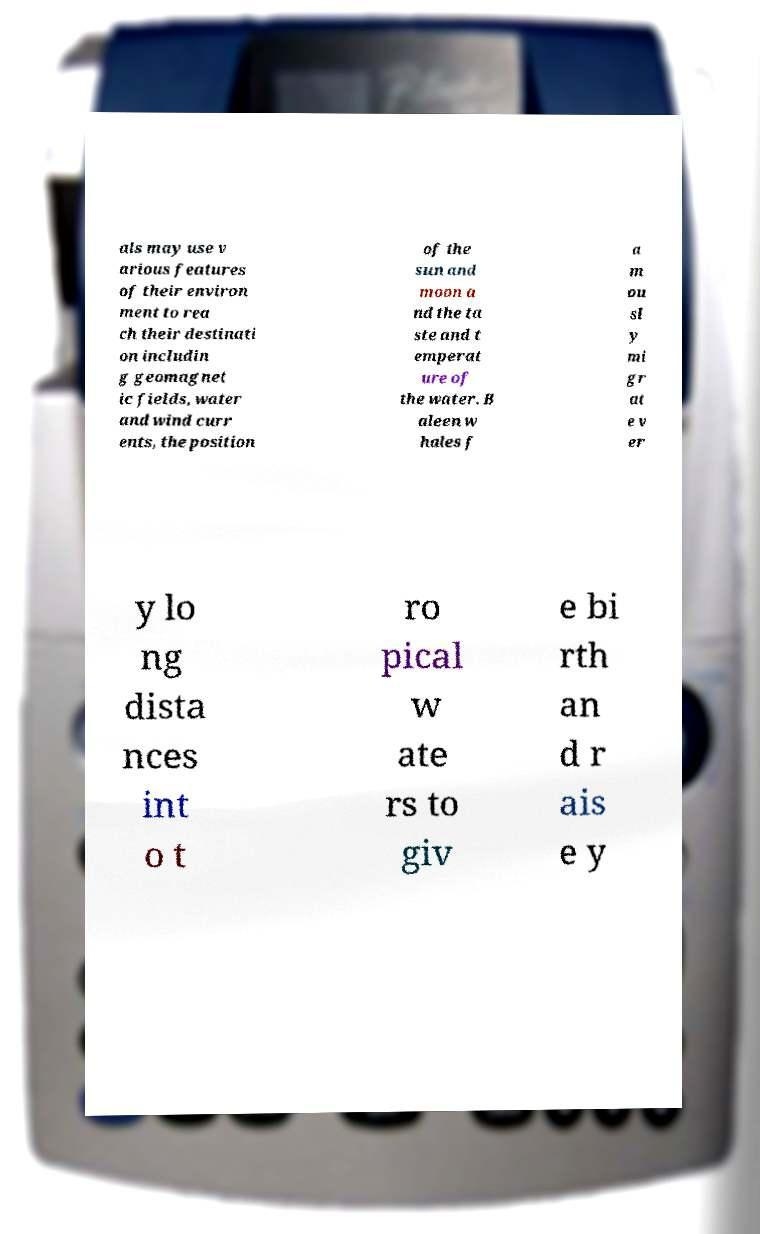What messages or text are displayed in this image? I need them in a readable, typed format. als may use v arious features of their environ ment to rea ch their destinati on includin g geomagnet ic fields, water and wind curr ents, the position of the sun and moon a nd the ta ste and t emperat ure of the water. B aleen w hales f a m ou sl y mi gr at e v er y lo ng dista nces int o t ro pical w ate rs to giv e bi rth an d r ais e y 